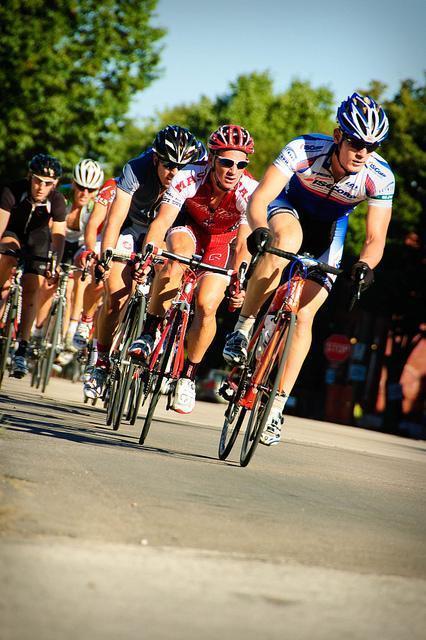How many bicycles can be seen?
Give a very brief answer. 4. How many people are there?
Give a very brief answer. 6. 